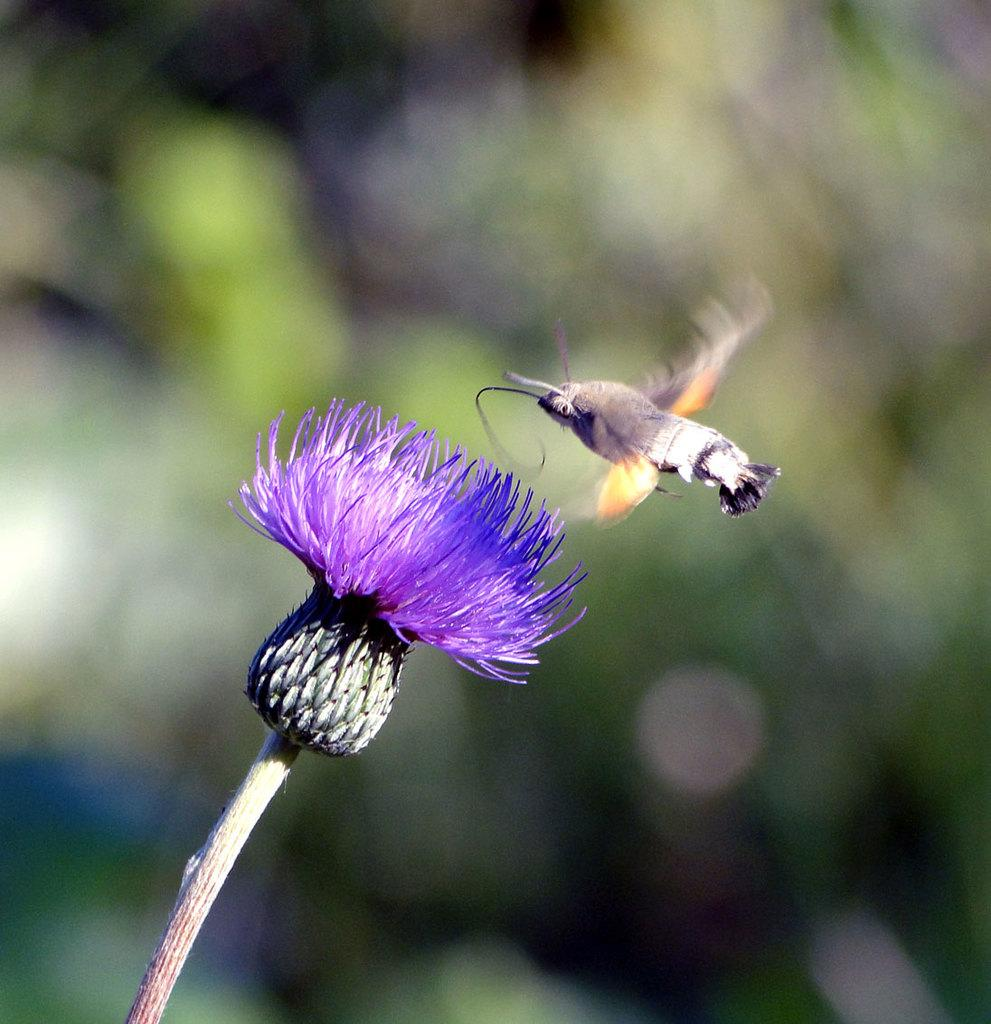What is on the flower in the image? There is a fly on a flower in the image. Can you describe the flower in the image? The flower has a stem. What can be observed about the background of the image? The background of the image is blurred. How does the fly kick the yoke in the image? There is no yoke or kicking action present in the image; it features a fly on a flower with a blurred background. 